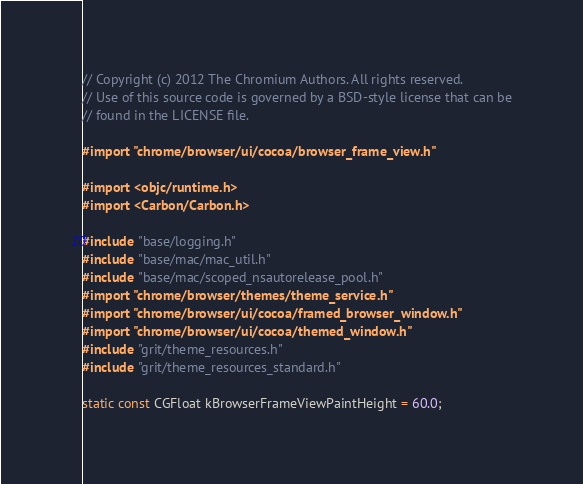<code> <loc_0><loc_0><loc_500><loc_500><_ObjectiveC_>// Copyright (c) 2012 The Chromium Authors. All rights reserved.
// Use of this source code is governed by a BSD-style license that can be
// found in the LICENSE file.

#import "chrome/browser/ui/cocoa/browser_frame_view.h"

#import <objc/runtime.h>
#import <Carbon/Carbon.h>

#include "base/logging.h"
#include "base/mac/mac_util.h"
#include "base/mac/scoped_nsautorelease_pool.h"
#import "chrome/browser/themes/theme_service.h"
#import "chrome/browser/ui/cocoa/framed_browser_window.h"
#import "chrome/browser/ui/cocoa/themed_window.h"
#include "grit/theme_resources.h"
#include "grit/theme_resources_standard.h"

static const CGFloat kBrowserFrameViewPaintHeight = 60.0;</code> 